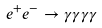<formula> <loc_0><loc_0><loc_500><loc_500>e ^ { + } e ^ { - } \rightarrow \gamma \gamma \gamma \gamma</formula> 